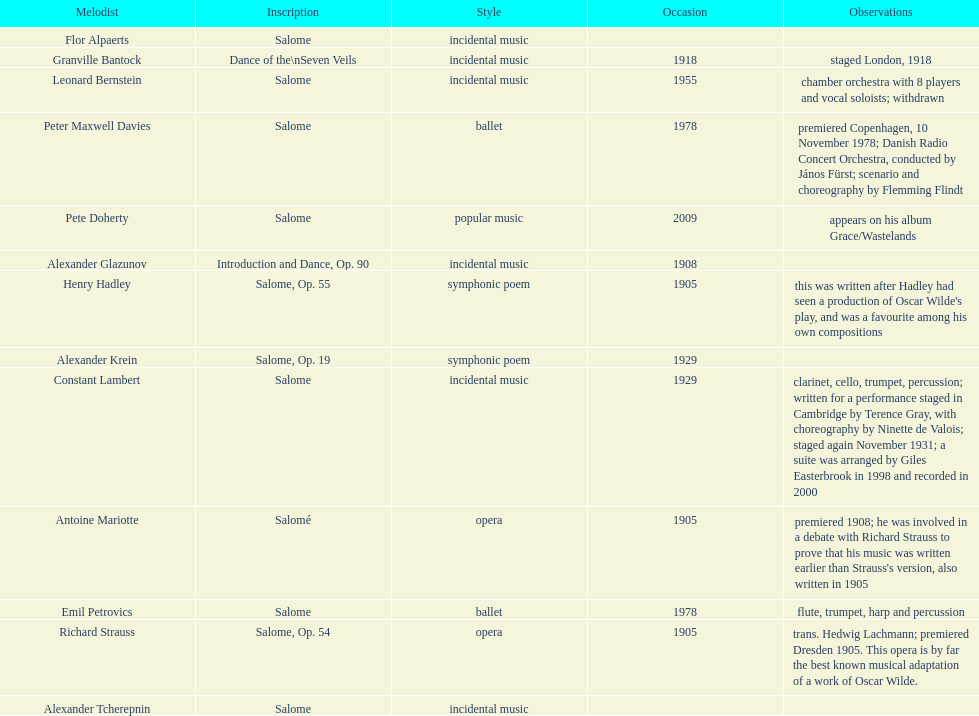How many works were made in the incidental music genre? 6. 